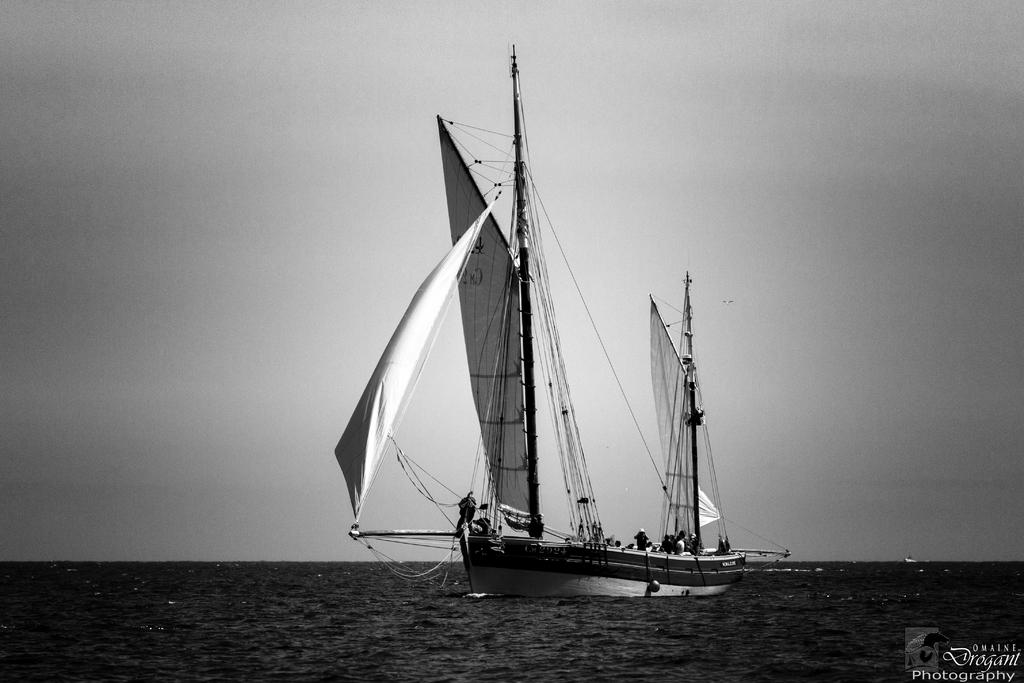What is the color scheme of the image? The image is black and white. What activity are the persons in the image engaged in? The persons in the image are riding in a boat on the water. What type of clothing can be seen in the image? Clothes are visible in the image. What objects are present in the image that might be used for tying or securing? Ropes are present in the image. What objects are present in the image that might be used for support or guidance? Poles are present in the image. What part of the natural environment is visible in the image? The sky is visible in the image. What type of art can be seen hanging on the wall in the image? There is no art or wall present in the image; it features persons riding in a boat on the water. What type of glue is being used to attach the cast to the person's arm in the image? There is no cast or person with an injured arm present in the image; it features persons riding in a boat on the water. 